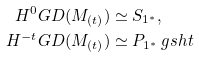Convert formula to latex. <formula><loc_0><loc_0><loc_500><loc_500>H ^ { 0 } G D ( M _ { ( t ) } ) & \simeq S _ { 1 ^ { \ast } } , \\ H ^ { - t } G D ( M _ { ( t ) } ) & \simeq P _ { 1 ^ { \ast } } \ g s h t</formula> 